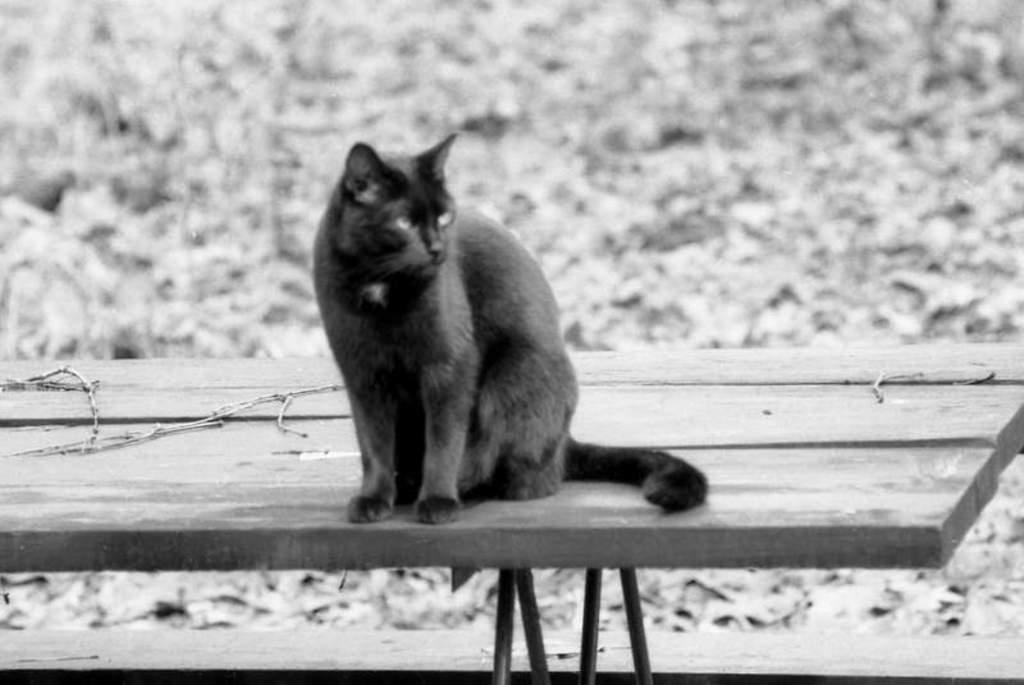What animal is present in the image? There is a cat in the image. Where is the cat located? The cat is sitting on a bench. Can you describe the background of the image? The background of the image is blurry. What is the color scheme of the image? The image is black and white. What type of trousers is the cat wearing in the image? Cats do not wear trousers, so this detail cannot be found in the image. 